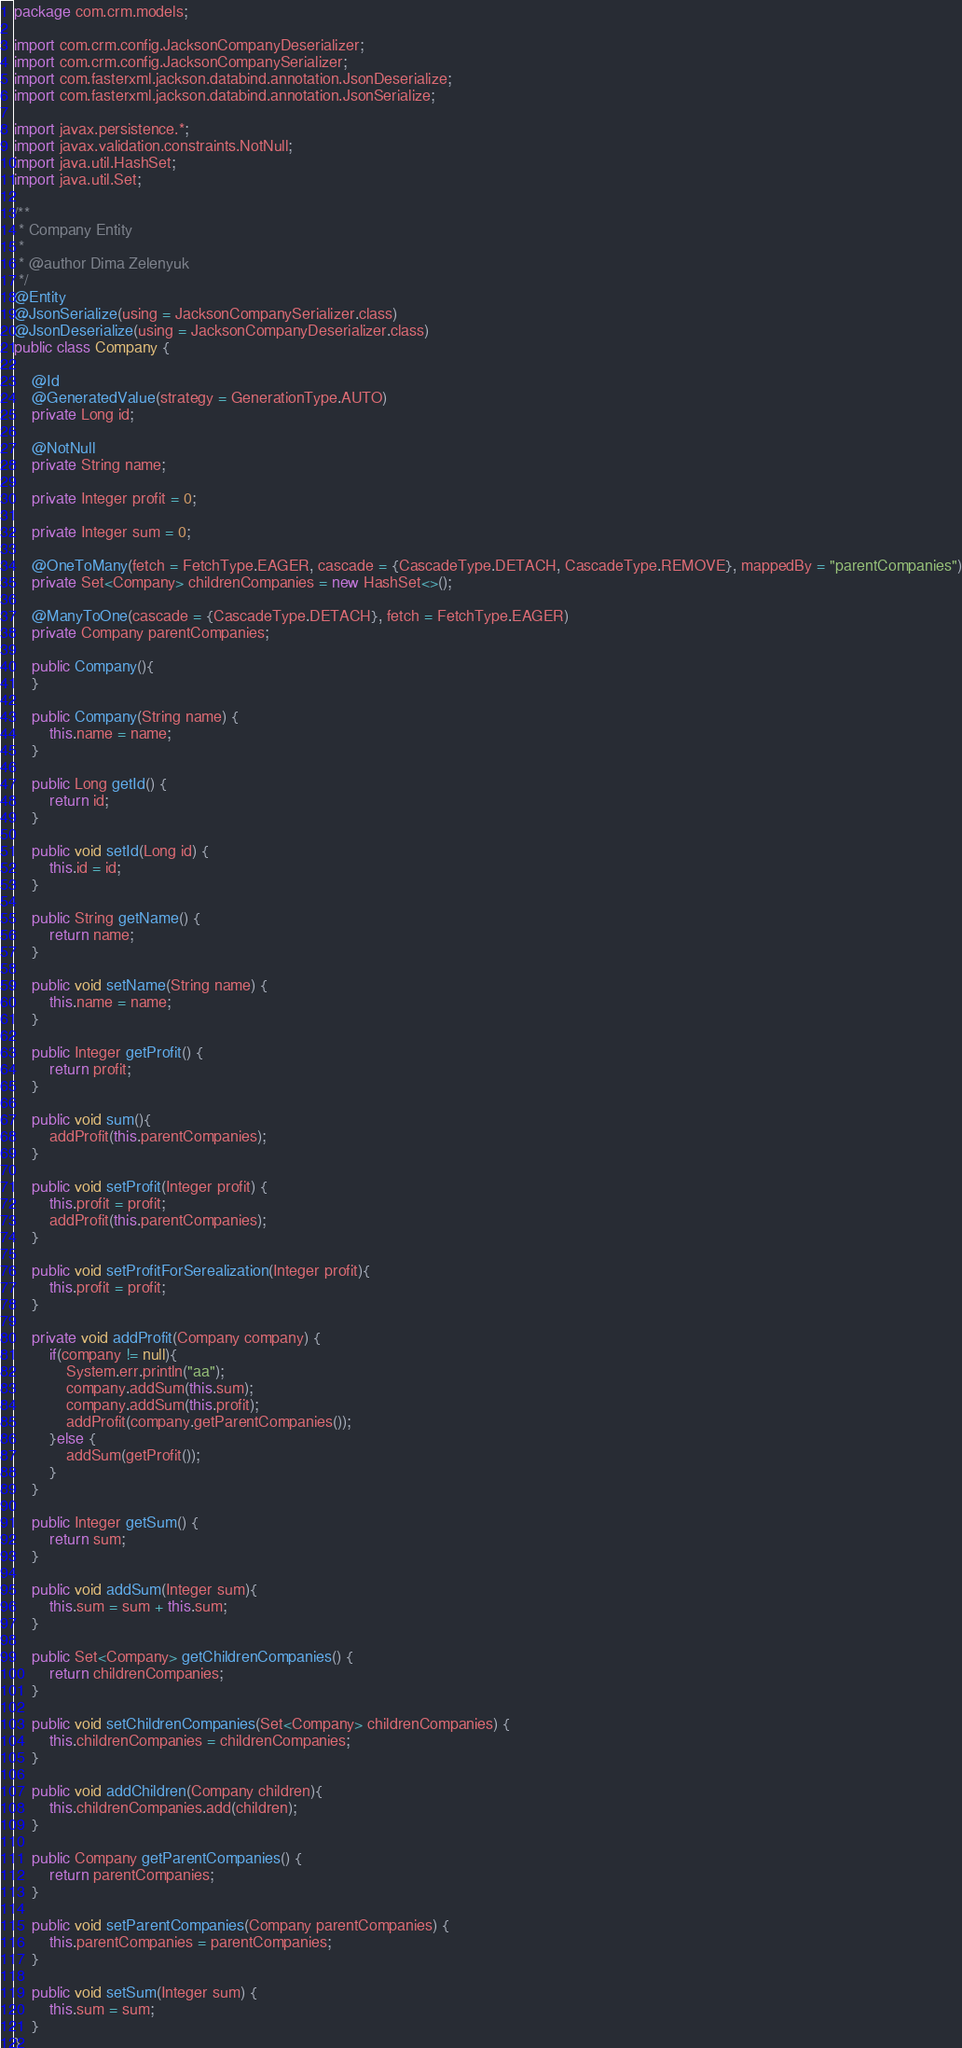<code> <loc_0><loc_0><loc_500><loc_500><_Java_>package com.crm.models;

import com.crm.config.JacksonCompanyDeserializer;
import com.crm.config.JacksonCompanySerializer;
import com.fasterxml.jackson.databind.annotation.JsonDeserialize;
import com.fasterxml.jackson.databind.annotation.JsonSerialize;

import javax.persistence.*;
import javax.validation.constraints.NotNull;
import java.util.HashSet;
import java.util.Set;

/**
 * Company Entity
 *
 * @author Dima Zelenyuk
 */
@Entity
@JsonSerialize(using = JacksonCompanySerializer.class)
@JsonDeserialize(using = JacksonCompanyDeserializer.class)
public class Company {

    @Id
    @GeneratedValue(strategy = GenerationType.AUTO)
    private Long id;

    @NotNull
    private String name;

    private Integer profit = 0;

    private Integer sum = 0;

    @OneToMany(fetch = FetchType.EAGER, cascade = {CascadeType.DETACH, CascadeType.REMOVE}, mappedBy = "parentCompanies")
    private Set<Company> childrenCompanies = new HashSet<>();

    @ManyToOne(cascade = {CascadeType.DETACH}, fetch = FetchType.EAGER)
    private Company parentCompanies;

    public Company(){
    }

    public Company(String name) {
        this.name = name;
    }

    public Long getId() {
        return id;
    }

    public void setId(Long id) {
        this.id = id;
    }

    public String getName() {
        return name;
    }

    public void setName(String name) {
        this.name = name;
    }

    public Integer getProfit() {
        return profit;
    }

    public void sum(){
        addProfit(this.parentCompanies);
    }

    public void setProfit(Integer profit) {
        this.profit = profit;
        addProfit(this.parentCompanies);
    }

    public void setProfitForSerealization(Integer profit){
        this.profit = profit;
    }

    private void addProfit(Company company) {
        if(company != null){
            System.err.println("aa");
            company.addSum(this.sum);
            company.addSum(this.profit);
            addProfit(company.getParentCompanies());
        }else {
            addSum(getProfit());
        }
    }

    public Integer getSum() {
        return sum;
    }

    public void addSum(Integer sum){
        this.sum = sum + this.sum;
    }

    public Set<Company> getChildrenCompanies() {
        return childrenCompanies;
    }

    public void setChildrenCompanies(Set<Company> childrenCompanies) {
        this.childrenCompanies = childrenCompanies;
    }

    public void addChildren(Company children){
        this.childrenCompanies.add(children);
    }

    public Company getParentCompanies() {
        return parentCompanies;
    }

    public void setParentCompanies(Company parentCompanies) {
        this.parentCompanies = parentCompanies;
    }

    public void setSum(Integer sum) {
        this.sum = sum;
    }
}
</code> 